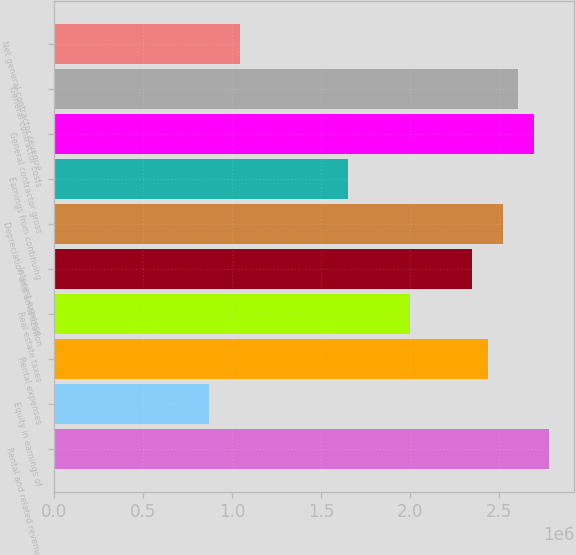Convert chart to OTSL. <chart><loc_0><loc_0><loc_500><loc_500><bar_chart><fcel>Rental and related revenue<fcel>Equity in earnings of<fcel>Rental expenses<fcel>Real estate taxes<fcel>Interest expense<fcel>Depreciation and amortization<fcel>Earnings from continuing<fcel>General contractor gross<fcel>General contractor costs<fcel>Net general contractor revenue<nl><fcel>2.78519e+06<fcel>870372<fcel>2.43704e+06<fcel>2.00186e+06<fcel>2.35e+06<fcel>2.52408e+06<fcel>1.65371e+06<fcel>2.69815e+06<fcel>2.61112e+06<fcel>1.04445e+06<nl></chart> 